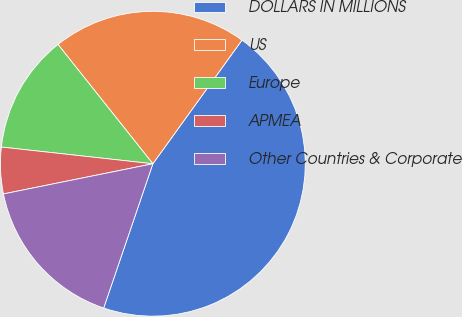Convert chart. <chart><loc_0><loc_0><loc_500><loc_500><pie_chart><fcel>DOLLARS IN MILLIONS<fcel>US<fcel>Europe<fcel>APMEA<fcel>Other Countries & Corporate<nl><fcel>45.29%<fcel>20.63%<fcel>12.56%<fcel>4.92%<fcel>16.6%<nl></chart> 